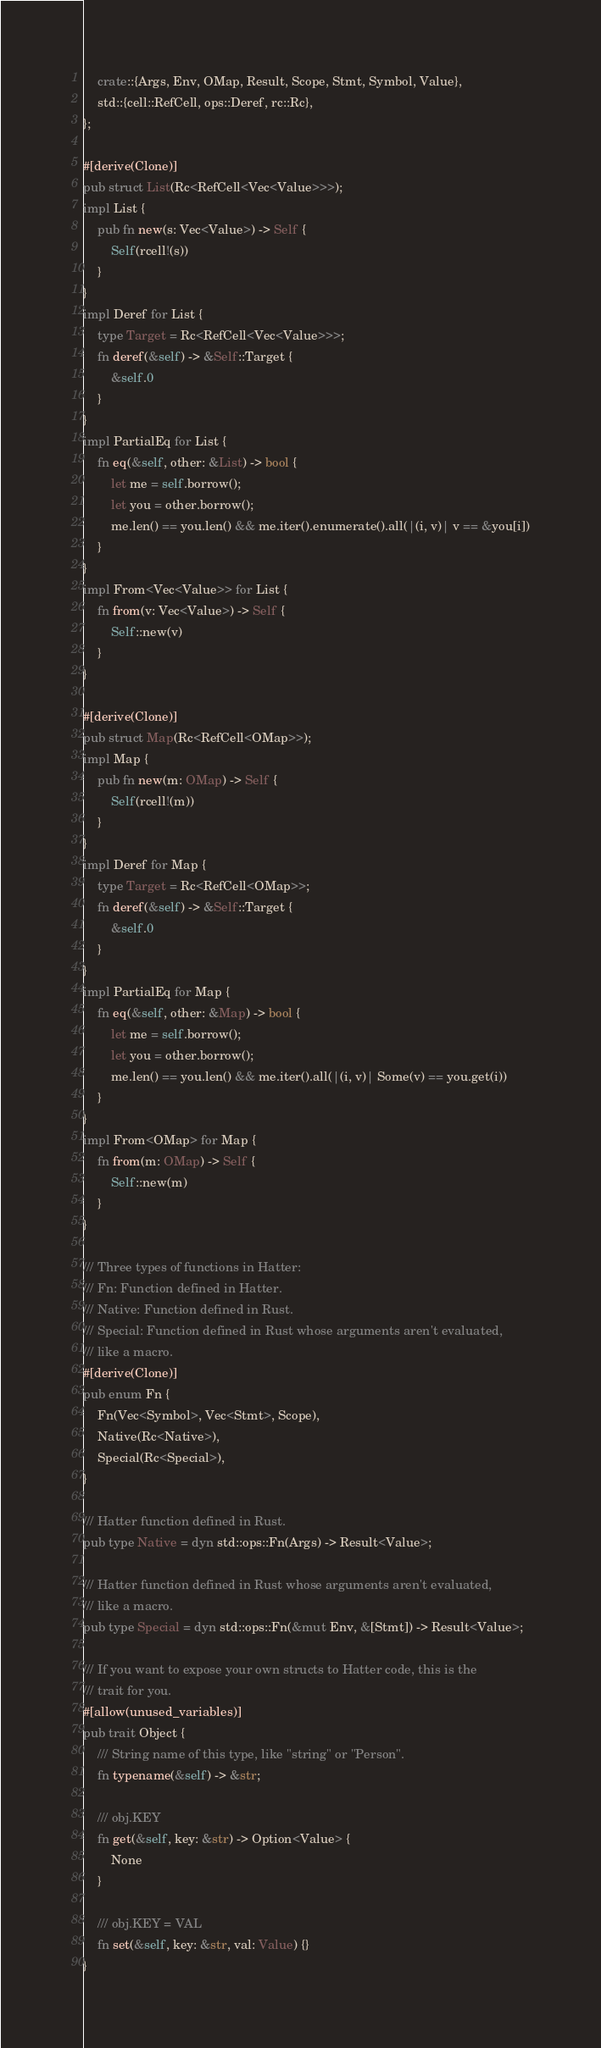<code> <loc_0><loc_0><loc_500><loc_500><_Rust_>    crate::{Args, Env, OMap, Result, Scope, Stmt, Symbol, Value},
    std::{cell::RefCell, ops::Deref, rc::Rc},
};

#[derive(Clone)]
pub struct List(Rc<RefCell<Vec<Value>>>);
impl List {
    pub fn new(s: Vec<Value>) -> Self {
        Self(rcell!(s))
    }
}
impl Deref for List {
    type Target = Rc<RefCell<Vec<Value>>>;
    fn deref(&self) -> &Self::Target {
        &self.0
    }
}
impl PartialEq for List {
    fn eq(&self, other: &List) -> bool {
        let me = self.borrow();
        let you = other.borrow();
        me.len() == you.len() && me.iter().enumerate().all(|(i, v)| v == &you[i])
    }
}
impl From<Vec<Value>> for List {
    fn from(v: Vec<Value>) -> Self {
        Self::new(v)
    }
}

#[derive(Clone)]
pub struct Map(Rc<RefCell<OMap>>);
impl Map {
    pub fn new(m: OMap) -> Self {
        Self(rcell!(m))
    }
}
impl Deref for Map {
    type Target = Rc<RefCell<OMap>>;
    fn deref(&self) -> &Self::Target {
        &self.0
    }
}
impl PartialEq for Map {
    fn eq(&self, other: &Map) -> bool {
        let me = self.borrow();
        let you = other.borrow();
        me.len() == you.len() && me.iter().all(|(i, v)| Some(v) == you.get(i))
    }
}
impl From<OMap> for Map {
    fn from(m: OMap) -> Self {
        Self::new(m)
    }
}

/// Three types of functions in Hatter:
/// Fn: Function defined in Hatter.
/// Native: Function defined in Rust.
/// Special: Function defined in Rust whose arguments aren't evaluated,
/// like a macro.
#[derive(Clone)]
pub enum Fn {
    Fn(Vec<Symbol>, Vec<Stmt>, Scope),
    Native(Rc<Native>),
    Special(Rc<Special>),
}

/// Hatter function defined in Rust.
pub type Native = dyn std::ops::Fn(Args) -> Result<Value>;

/// Hatter function defined in Rust whose arguments aren't evaluated,
/// like a macro.
pub type Special = dyn std::ops::Fn(&mut Env, &[Stmt]) -> Result<Value>;

/// If you want to expose your own structs to Hatter code, this is the
/// trait for you.
#[allow(unused_variables)]
pub trait Object {
    /// String name of this type, like "string" or "Person".
    fn typename(&self) -> &str;

    /// obj.KEY
    fn get(&self, key: &str) -> Option<Value> {
        None
    }

    /// obj.KEY = VAL
    fn set(&self, key: &str, val: Value) {}
}
</code> 